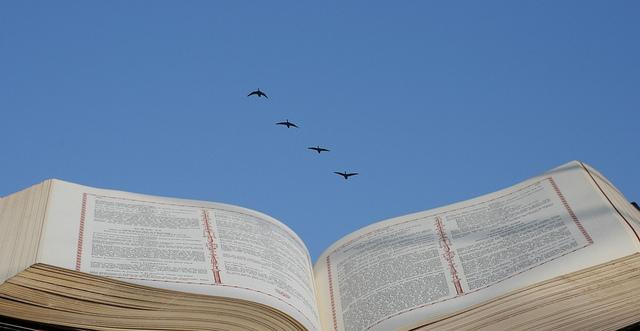Birds seen here are likely doing what?

Choices:
A) attacking
B) flyover
C) migrating
D) landing migrating 